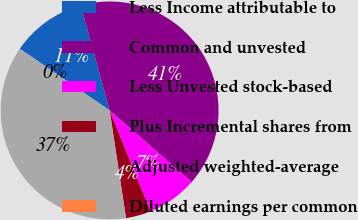<chart> <loc_0><loc_0><loc_500><loc_500><pie_chart><fcel>Less Income attributable to<fcel>Common and unvested<fcel>Less Unvested stock-based<fcel>Plus Incremental shares from<fcel>Adjusted weighted-average<fcel>Diluted earnings per common<nl><fcel>11.16%<fcel>40.7%<fcel>7.44%<fcel>3.72%<fcel>36.98%<fcel>0.0%<nl></chart> 